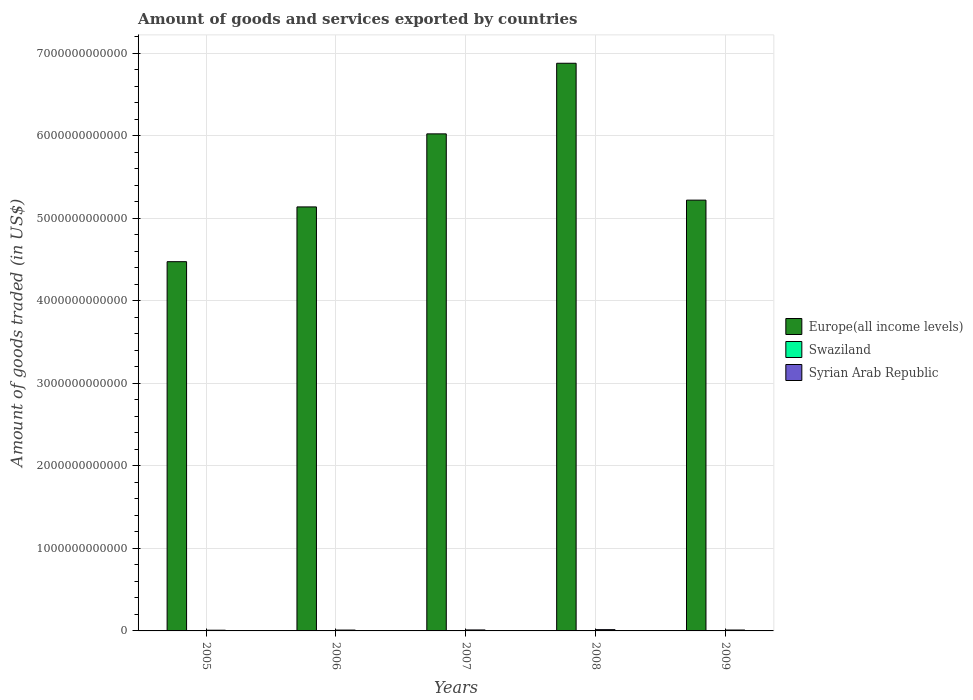Are the number of bars on each tick of the X-axis equal?
Ensure brevity in your answer.  Yes. How many bars are there on the 2nd tick from the left?
Offer a terse response. 3. How many bars are there on the 3rd tick from the right?
Your response must be concise. 3. In how many cases, is the number of bars for a given year not equal to the number of legend labels?
Provide a short and direct response. 0. What is the total amount of goods and services exported in Syrian Arab Republic in 2008?
Provide a succinct answer. 1.53e+1. Across all years, what is the maximum total amount of goods and services exported in Syrian Arab Republic?
Your answer should be compact. 1.53e+1. Across all years, what is the minimum total amount of goods and services exported in Europe(all income levels)?
Ensure brevity in your answer.  4.47e+12. In which year was the total amount of goods and services exported in Syrian Arab Republic maximum?
Your answer should be very brief. 2008. What is the total total amount of goods and services exported in Syrian Arab Republic in the graph?
Make the answer very short. 5.68e+1. What is the difference between the total amount of goods and services exported in Swaziland in 2007 and that in 2009?
Give a very brief answer. 6.09e+07. What is the difference between the total amount of goods and services exported in Europe(all income levels) in 2008 and the total amount of goods and services exported in Swaziland in 2005?
Offer a terse response. 6.88e+12. What is the average total amount of goods and services exported in Syrian Arab Republic per year?
Keep it short and to the point. 1.14e+1. In the year 2008, what is the difference between the total amount of goods and services exported in Syrian Arab Republic and total amount of goods and services exported in Europe(all income levels)?
Ensure brevity in your answer.  -6.86e+12. In how many years, is the total amount of goods and services exported in Swaziland greater than 1800000000000 US$?
Make the answer very short. 0. What is the ratio of the total amount of goods and services exported in Swaziland in 2005 to that in 2009?
Provide a succinct answer. 1.02. Is the difference between the total amount of goods and services exported in Syrian Arab Republic in 2005 and 2007 greater than the difference between the total amount of goods and services exported in Europe(all income levels) in 2005 and 2007?
Ensure brevity in your answer.  Yes. What is the difference between the highest and the second highest total amount of goods and services exported in Syrian Arab Republic?
Your answer should be compact. 3.58e+09. What is the difference between the highest and the lowest total amount of goods and services exported in Syrian Arab Republic?
Your response must be concise. 6.73e+09. In how many years, is the total amount of goods and services exported in Syrian Arab Republic greater than the average total amount of goods and services exported in Syrian Arab Republic taken over all years?
Keep it short and to the point. 2. What does the 1st bar from the left in 2008 represents?
Give a very brief answer. Europe(all income levels). What does the 2nd bar from the right in 2005 represents?
Offer a terse response. Swaziland. How many bars are there?
Keep it short and to the point. 15. Are all the bars in the graph horizontal?
Keep it short and to the point. No. How many years are there in the graph?
Keep it short and to the point. 5. What is the difference between two consecutive major ticks on the Y-axis?
Your response must be concise. 1.00e+12. Are the values on the major ticks of Y-axis written in scientific E-notation?
Your answer should be compact. No. Where does the legend appear in the graph?
Your response must be concise. Center right. What is the title of the graph?
Your answer should be compact. Amount of goods and services exported by countries. What is the label or title of the Y-axis?
Provide a succinct answer. Amount of goods traded (in US$). What is the Amount of goods traded (in US$) in Europe(all income levels) in 2005?
Your response must be concise. 4.47e+12. What is the Amount of goods traded (in US$) in Swaziland in 2005?
Your answer should be compact. 1.60e+09. What is the Amount of goods traded (in US$) in Syrian Arab Republic in 2005?
Your answer should be very brief. 8.60e+09. What is the Amount of goods traded (in US$) in Europe(all income levels) in 2006?
Provide a succinct answer. 5.14e+12. What is the Amount of goods traded (in US$) of Swaziland in 2006?
Offer a very short reply. 1.56e+09. What is the Amount of goods traded (in US$) in Syrian Arab Republic in 2006?
Ensure brevity in your answer.  1.02e+1. What is the Amount of goods traded (in US$) in Europe(all income levels) in 2007?
Offer a terse response. 6.02e+12. What is the Amount of goods traded (in US$) of Swaziland in 2007?
Provide a short and direct response. 1.63e+09. What is the Amount of goods traded (in US$) in Syrian Arab Republic in 2007?
Your answer should be very brief. 1.18e+1. What is the Amount of goods traded (in US$) of Europe(all income levels) in 2008?
Keep it short and to the point. 6.88e+12. What is the Amount of goods traded (in US$) in Swaziland in 2008?
Offer a very short reply. 1.49e+09. What is the Amount of goods traded (in US$) in Syrian Arab Republic in 2008?
Your answer should be compact. 1.53e+1. What is the Amount of goods traded (in US$) in Europe(all income levels) in 2009?
Your response must be concise. 5.22e+12. What is the Amount of goods traded (in US$) of Swaziland in 2009?
Offer a very short reply. 1.56e+09. What is the Amount of goods traded (in US$) of Syrian Arab Republic in 2009?
Make the answer very short. 1.09e+1. Across all years, what is the maximum Amount of goods traded (in US$) in Europe(all income levels)?
Keep it short and to the point. 6.88e+12. Across all years, what is the maximum Amount of goods traded (in US$) in Swaziland?
Offer a terse response. 1.63e+09. Across all years, what is the maximum Amount of goods traded (in US$) in Syrian Arab Republic?
Your answer should be very brief. 1.53e+1. Across all years, what is the minimum Amount of goods traded (in US$) in Europe(all income levels)?
Provide a short and direct response. 4.47e+12. Across all years, what is the minimum Amount of goods traded (in US$) in Swaziland?
Ensure brevity in your answer.  1.49e+09. Across all years, what is the minimum Amount of goods traded (in US$) in Syrian Arab Republic?
Offer a terse response. 8.60e+09. What is the total Amount of goods traded (in US$) in Europe(all income levels) in the graph?
Ensure brevity in your answer.  2.77e+13. What is the total Amount of goods traded (in US$) of Swaziland in the graph?
Your response must be concise. 7.84e+09. What is the total Amount of goods traded (in US$) in Syrian Arab Republic in the graph?
Your answer should be compact. 5.68e+1. What is the difference between the Amount of goods traded (in US$) in Europe(all income levels) in 2005 and that in 2006?
Provide a succinct answer. -6.64e+11. What is the difference between the Amount of goods traded (in US$) of Swaziland in 2005 and that in 2006?
Provide a short and direct response. 4.07e+07. What is the difference between the Amount of goods traded (in US$) of Syrian Arab Republic in 2005 and that in 2006?
Your answer should be compact. -1.64e+09. What is the difference between the Amount of goods traded (in US$) in Europe(all income levels) in 2005 and that in 2007?
Give a very brief answer. -1.55e+12. What is the difference between the Amount of goods traded (in US$) in Swaziland in 2005 and that in 2007?
Give a very brief answer. -2.45e+07. What is the difference between the Amount of goods traded (in US$) in Syrian Arab Republic in 2005 and that in 2007?
Offer a terse response. -3.15e+09. What is the difference between the Amount of goods traded (in US$) of Europe(all income levels) in 2005 and that in 2008?
Keep it short and to the point. -2.40e+12. What is the difference between the Amount of goods traded (in US$) in Swaziland in 2005 and that in 2008?
Offer a very short reply. 1.12e+08. What is the difference between the Amount of goods traded (in US$) in Syrian Arab Republic in 2005 and that in 2008?
Offer a terse response. -6.73e+09. What is the difference between the Amount of goods traded (in US$) in Europe(all income levels) in 2005 and that in 2009?
Offer a very short reply. -7.46e+11. What is the difference between the Amount of goods traded (in US$) in Swaziland in 2005 and that in 2009?
Give a very brief answer. 3.64e+07. What is the difference between the Amount of goods traded (in US$) in Syrian Arab Republic in 2005 and that in 2009?
Give a very brief answer. -2.28e+09. What is the difference between the Amount of goods traded (in US$) of Europe(all income levels) in 2006 and that in 2007?
Provide a short and direct response. -8.85e+11. What is the difference between the Amount of goods traded (in US$) of Swaziland in 2006 and that in 2007?
Give a very brief answer. -6.52e+07. What is the difference between the Amount of goods traded (in US$) in Syrian Arab Republic in 2006 and that in 2007?
Make the answer very short. -1.51e+09. What is the difference between the Amount of goods traded (in US$) of Europe(all income levels) in 2006 and that in 2008?
Offer a very short reply. -1.74e+12. What is the difference between the Amount of goods traded (in US$) of Swaziland in 2006 and that in 2008?
Your response must be concise. 7.14e+07. What is the difference between the Amount of goods traded (in US$) of Syrian Arab Republic in 2006 and that in 2008?
Your answer should be very brief. -5.09e+09. What is the difference between the Amount of goods traded (in US$) in Europe(all income levels) in 2006 and that in 2009?
Offer a terse response. -8.20e+1. What is the difference between the Amount of goods traded (in US$) of Swaziland in 2006 and that in 2009?
Provide a short and direct response. -4.34e+06. What is the difference between the Amount of goods traded (in US$) in Syrian Arab Republic in 2006 and that in 2009?
Provide a succinct answer. -6.39e+08. What is the difference between the Amount of goods traded (in US$) in Europe(all income levels) in 2007 and that in 2008?
Your answer should be compact. -8.55e+11. What is the difference between the Amount of goods traded (in US$) in Swaziland in 2007 and that in 2008?
Offer a terse response. 1.37e+08. What is the difference between the Amount of goods traded (in US$) in Syrian Arab Republic in 2007 and that in 2008?
Provide a short and direct response. -3.58e+09. What is the difference between the Amount of goods traded (in US$) in Europe(all income levels) in 2007 and that in 2009?
Ensure brevity in your answer.  8.03e+11. What is the difference between the Amount of goods traded (in US$) of Swaziland in 2007 and that in 2009?
Provide a short and direct response. 6.09e+07. What is the difference between the Amount of goods traded (in US$) in Syrian Arab Republic in 2007 and that in 2009?
Provide a succinct answer. 8.72e+08. What is the difference between the Amount of goods traded (in US$) in Europe(all income levels) in 2008 and that in 2009?
Provide a short and direct response. 1.66e+12. What is the difference between the Amount of goods traded (in US$) in Swaziland in 2008 and that in 2009?
Your response must be concise. -7.58e+07. What is the difference between the Amount of goods traded (in US$) in Syrian Arab Republic in 2008 and that in 2009?
Your answer should be very brief. 4.45e+09. What is the difference between the Amount of goods traded (in US$) in Europe(all income levels) in 2005 and the Amount of goods traded (in US$) in Swaziland in 2006?
Your answer should be very brief. 4.47e+12. What is the difference between the Amount of goods traded (in US$) of Europe(all income levels) in 2005 and the Amount of goods traded (in US$) of Syrian Arab Republic in 2006?
Offer a terse response. 4.46e+12. What is the difference between the Amount of goods traded (in US$) in Swaziland in 2005 and the Amount of goods traded (in US$) in Syrian Arab Republic in 2006?
Make the answer very short. -8.64e+09. What is the difference between the Amount of goods traded (in US$) of Europe(all income levels) in 2005 and the Amount of goods traded (in US$) of Swaziland in 2007?
Your answer should be compact. 4.47e+12. What is the difference between the Amount of goods traded (in US$) in Europe(all income levels) in 2005 and the Amount of goods traded (in US$) in Syrian Arab Republic in 2007?
Your answer should be very brief. 4.46e+12. What is the difference between the Amount of goods traded (in US$) in Swaziland in 2005 and the Amount of goods traded (in US$) in Syrian Arab Republic in 2007?
Ensure brevity in your answer.  -1.02e+1. What is the difference between the Amount of goods traded (in US$) of Europe(all income levels) in 2005 and the Amount of goods traded (in US$) of Swaziland in 2008?
Provide a short and direct response. 4.47e+12. What is the difference between the Amount of goods traded (in US$) of Europe(all income levels) in 2005 and the Amount of goods traded (in US$) of Syrian Arab Republic in 2008?
Give a very brief answer. 4.46e+12. What is the difference between the Amount of goods traded (in US$) of Swaziland in 2005 and the Amount of goods traded (in US$) of Syrian Arab Republic in 2008?
Make the answer very short. -1.37e+1. What is the difference between the Amount of goods traded (in US$) in Europe(all income levels) in 2005 and the Amount of goods traded (in US$) in Swaziland in 2009?
Provide a succinct answer. 4.47e+12. What is the difference between the Amount of goods traded (in US$) of Europe(all income levels) in 2005 and the Amount of goods traded (in US$) of Syrian Arab Republic in 2009?
Your answer should be compact. 4.46e+12. What is the difference between the Amount of goods traded (in US$) in Swaziland in 2005 and the Amount of goods traded (in US$) in Syrian Arab Republic in 2009?
Your response must be concise. -9.28e+09. What is the difference between the Amount of goods traded (in US$) of Europe(all income levels) in 2006 and the Amount of goods traded (in US$) of Swaziland in 2007?
Give a very brief answer. 5.14e+12. What is the difference between the Amount of goods traded (in US$) of Europe(all income levels) in 2006 and the Amount of goods traded (in US$) of Syrian Arab Republic in 2007?
Your response must be concise. 5.13e+12. What is the difference between the Amount of goods traded (in US$) in Swaziland in 2006 and the Amount of goods traded (in US$) in Syrian Arab Republic in 2007?
Your answer should be very brief. -1.02e+1. What is the difference between the Amount of goods traded (in US$) in Europe(all income levels) in 2006 and the Amount of goods traded (in US$) in Swaziland in 2008?
Make the answer very short. 5.14e+12. What is the difference between the Amount of goods traded (in US$) in Europe(all income levels) in 2006 and the Amount of goods traded (in US$) in Syrian Arab Republic in 2008?
Provide a succinct answer. 5.12e+12. What is the difference between the Amount of goods traded (in US$) in Swaziland in 2006 and the Amount of goods traded (in US$) in Syrian Arab Republic in 2008?
Make the answer very short. -1.38e+1. What is the difference between the Amount of goods traded (in US$) of Europe(all income levels) in 2006 and the Amount of goods traded (in US$) of Swaziland in 2009?
Your response must be concise. 5.14e+12. What is the difference between the Amount of goods traded (in US$) of Europe(all income levels) in 2006 and the Amount of goods traded (in US$) of Syrian Arab Republic in 2009?
Your response must be concise. 5.13e+12. What is the difference between the Amount of goods traded (in US$) of Swaziland in 2006 and the Amount of goods traded (in US$) of Syrian Arab Republic in 2009?
Offer a very short reply. -9.32e+09. What is the difference between the Amount of goods traded (in US$) of Europe(all income levels) in 2007 and the Amount of goods traded (in US$) of Swaziland in 2008?
Your answer should be very brief. 6.02e+12. What is the difference between the Amount of goods traded (in US$) of Europe(all income levels) in 2007 and the Amount of goods traded (in US$) of Syrian Arab Republic in 2008?
Your answer should be compact. 6.01e+12. What is the difference between the Amount of goods traded (in US$) in Swaziland in 2007 and the Amount of goods traded (in US$) in Syrian Arab Republic in 2008?
Provide a short and direct response. -1.37e+1. What is the difference between the Amount of goods traded (in US$) of Europe(all income levels) in 2007 and the Amount of goods traded (in US$) of Swaziland in 2009?
Your answer should be very brief. 6.02e+12. What is the difference between the Amount of goods traded (in US$) in Europe(all income levels) in 2007 and the Amount of goods traded (in US$) in Syrian Arab Republic in 2009?
Offer a terse response. 6.01e+12. What is the difference between the Amount of goods traded (in US$) in Swaziland in 2007 and the Amount of goods traded (in US$) in Syrian Arab Republic in 2009?
Offer a terse response. -9.26e+09. What is the difference between the Amount of goods traded (in US$) of Europe(all income levels) in 2008 and the Amount of goods traded (in US$) of Swaziland in 2009?
Provide a succinct answer. 6.88e+12. What is the difference between the Amount of goods traded (in US$) of Europe(all income levels) in 2008 and the Amount of goods traded (in US$) of Syrian Arab Republic in 2009?
Your response must be concise. 6.87e+12. What is the difference between the Amount of goods traded (in US$) in Swaziland in 2008 and the Amount of goods traded (in US$) in Syrian Arab Republic in 2009?
Your response must be concise. -9.39e+09. What is the average Amount of goods traded (in US$) in Europe(all income levels) per year?
Your response must be concise. 5.55e+12. What is the average Amount of goods traded (in US$) in Swaziland per year?
Provide a short and direct response. 1.57e+09. What is the average Amount of goods traded (in US$) in Syrian Arab Republic per year?
Make the answer very short. 1.14e+1. In the year 2005, what is the difference between the Amount of goods traded (in US$) in Europe(all income levels) and Amount of goods traded (in US$) in Swaziland?
Offer a terse response. 4.47e+12. In the year 2005, what is the difference between the Amount of goods traded (in US$) of Europe(all income levels) and Amount of goods traded (in US$) of Syrian Arab Republic?
Ensure brevity in your answer.  4.47e+12. In the year 2005, what is the difference between the Amount of goods traded (in US$) of Swaziland and Amount of goods traded (in US$) of Syrian Arab Republic?
Give a very brief answer. -7.00e+09. In the year 2006, what is the difference between the Amount of goods traded (in US$) of Europe(all income levels) and Amount of goods traded (in US$) of Swaziland?
Your response must be concise. 5.14e+12. In the year 2006, what is the difference between the Amount of goods traded (in US$) in Europe(all income levels) and Amount of goods traded (in US$) in Syrian Arab Republic?
Provide a succinct answer. 5.13e+12. In the year 2006, what is the difference between the Amount of goods traded (in US$) of Swaziland and Amount of goods traded (in US$) of Syrian Arab Republic?
Give a very brief answer. -8.68e+09. In the year 2007, what is the difference between the Amount of goods traded (in US$) in Europe(all income levels) and Amount of goods traded (in US$) in Swaziland?
Your answer should be compact. 6.02e+12. In the year 2007, what is the difference between the Amount of goods traded (in US$) of Europe(all income levels) and Amount of goods traded (in US$) of Syrian Arab Republic?
Provide a short and direct response. 6.01e+12. In the year 2007, what is the difference between the Amount of goods traded (in US$) of Swaziland and Amount of goods traded (in US$) of Syrian Arab Republic?
Offer a very short reply. -1.01e+1. In the year 2008, what is the difference between the Amount of goods traded (in US$) in Europe(all income levels) and Amount of goods traded (in US$) in Swaziland?
Keep it short and to the point. 6.88e+12. In the year 2008, what is the difference between the Amount of goods traded (in US$) of Europe(all income levels) and Amount of goods traded (in US$) of Syrian Arab Republic?
Your answer should be very brief. 6.86e+12. In the year 2008, what is the difference between the Amount of goods traded (in US$) in Swaziland and Amount of goods traded (in US$) in Syrian Arab Republic?
Ensure brevity in your answer.  -1.38e+1. In the year 2009, what is the difference between the Amount of goods traded (in US$) of Europe(all income levels) and Amount of goods traded (in US$) of Swaziland?
Offer a very short reply. 5.22e+12. In the year 2009, what is the difference between the Amount of goods traded (in US$) of Europe(all income levels) and Amount of goods traded (in US$) of Syrian Arab Republic?
Offer a very short reply. 5.21e+12. In the year 2009, what is the difference between the Amount of goods traded (in US$) in Swaziland and Amount of goods traded (in US$) in Syrian Arab Republic?
Offer a terse response. -9.32e+09. What is the ratio of the Amount of goods traded (in US$) in Europe(all income levels) in 2005 to that in 2006?
Provide a succinct answer. 0.87. What is the ratio of the Amount of goods traded (in US$) of Swaziland in 2005 to that in 2006?
Keep it short and to the point. 1.03. What is the ratio of the Amount of goods traded (in US$) of Syrian Arab Republic in 2005 to that in 2006?
Provide a short and direct response. 0.84. What is the ratio of the Amount of goods traded (in US$) of Europe(all income levels) in 2005 to that in 2007?
Offer a terse response. 0.74. What is the ratio of the Amount of goods traded (in US$) of Swaziland in 2005 to that in 2007?
Offer a terse response. 0.98. What is the ratio of the Amount of goods traded (in US$) in Syrian Arab Republic in 2005 to that in 2007?
Your answer should be compact. 0.73. What is the ratio of the Amount of goods traded (in US$) of Europe(all income levels) in 2005 to that in 2008?
Offer a very short reply. 0.65. What is the ratio of the Amount of goods traded (in US$) in Swaziland in 2005 to that in 2008?
Keep it short and to the point. 1.08. What is the ratio of the Amount of goods traded (in US$) in Syrian Arab Republic in 2005 to that in 2008?
Your answer should be compact. 0.56. What is the ratio of the Amount of goods traded (in US$) in Europe(all income levels) in 2005 to that in 2009?
Offer a terse response. 0.86. What is the ratio of the Amount of goods traded (in US$) in Swaziland in 2005 to that in 2009?
Offer a very short reply. 1.02. What is the ratio of the Amount of goods traded (in US$) of Syrian Arab Republic in 2005 to that in 2009?
Make the answer very short. 0.79. What is the ratio of the Amount of goods traded (in US$) of Europe(all income levels) in 2006 to that in 2007?
Offer a terse response. 0.85. What is the ratio of the Amount of goods traded (in US$) of Swaziland in 2006 to that in 2007?
Ensure brevity in your answer.  0.96. What is the ratio of the Amount of goods traded (in US$) in Syrian Arab Republic in 2006 to that in 2007?
Provide a succinct answer. 0.87. What is the ratio of the Amount of goods traded (in US$) of Europe(all income levels) in 2006 to that in 2008?
Provide a short and direct response. 0.75. What is the ratio of the Amount of goods traded (in US$) of Swaziland in 2006 to that in 2008?
Provide a succinct answer. 1.05. What is the ratio of the Amount of goods traded (in US$) in Syrian Arab Republic in 2006 to that in 2008?
Your response must be concise. 0.67. What is the ratio of the Amount of goods traded (in US$) of Europe(all income levels) in 2006 to that in 2009?
Give a very brief answer. 0.98. What is the ratio of the Amount of goods traded (in US$) in Swaziland in 2006 to that in 2009?
Your response must be concise. 1. What is the ratio of the Amount of goods traded (in US$) of Syrian Arab Republic in 2006 to that in 2009?
Provide a short and direct response. 0.94. What is the ratio of the Amount of goods traded (in US$) in Europe(all income levels) in 2007 to that in 2008?
Offer a very short reply. 0.88. What is the ratio of the Amount of goods traded (in US$) in Swaziland in 2007 to that in 2008?
Offer a very short reply. 1.09. What is the ratio of the Amount of goods traded (in US$) of Syrian Arab Republic in 2007 to that in 2008?
Keep it short and to the point. 0.77. What is the ratio of the Amount of goods traded (in US$) of Europe(all income levels) in 2007 to that in 2009?
Your answer should be very brief. 1.15. What is the ratio of the Amount of goods traded (in US$) in Swaziland in 2007 to that in 2009?
Give a very brief answer. 1.04. What is the ratio of the Amount of goods traded (in US$) of Syrian Arab Republic in 2007 to that in 2009?
Provide a succinct answer. 1.08. What is the ratio of the Amount of goods traded (in US$) in Europe(all income levels) in 2008 to that in 2009?
Your answer should be compact. 1.32. What is the ratio of the Amount of goods traded (in US$) in Swaziland in 2008 to that in 2009?
Ensure brevity in your answer.  0.95. What is the ratio of the Amount of goods traded (in US$) in Syrian Arab Republic in 2008 to that in 2009?
Offer a very short reply. 1.41. What is the difference between the highest and the second highest Amount of goods traded (in US$) of Europe(all income levels)?
Ensure brevity in your answer.  8.55e+11. What is the difference between the highest and the second highest Amount of goods traded (in US$) in Swaziland?
Give a very brief answer. 2.45e+07. What is the difference between the highest and the second highest Amount of goods traded (in US$) of Syrian Arab Republic?
Provide a short and direct response. 3.58e+09. What is the difference between the highest and the lowest Amount of goods traded (in US$) of Europe(all income levels)?
Make the answer very short. 2.40e+12. What is the difference between the highest and the lowest Amount of goods traded (in US$) in Swaziland?
Ensure brevity in your answer.  1.37e+08. What is the difference between the highest and the lowest Amount of goods traded (in US$) of Syrian Arab Republic?
Make the answer very short. 6.73e+09. 